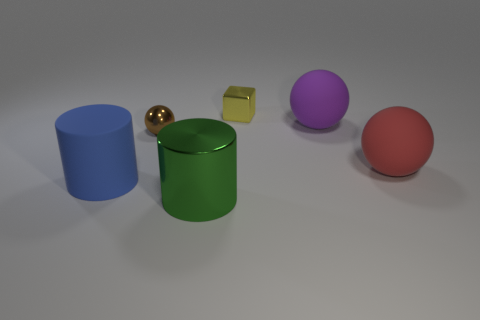There is a rubber ball behind the big matte ball that is in front of the large matte thing behind the tiny brown ball; how big is it?
Give a very brief answer. Large. What number of other things are the same color as the large rubber cylinder?
Provide a short and direct response. 0. There is a tiny object on the left side of the tiny yellow block; does it have the same color as the big shiny object?
Provide a short and direct response. No. How many objects are either blue rubber cylinders or metal objects?
Keep it short and to the point. 4. There is a thing that is in front of the blue thing; what is its color?
Offer a very short reply. Green. Are there fewer large blue things that are right of the green cylinder than cyan cylinders?
Give a very brief answer. No. Are there any other things that are the same size as the red rubber ball?
Your response must be concise. Yes. Is the material of the large blue cylinder the same as the large purple object?
Provide a succinct answer. Yes. What number of objects are either large green objects on the right side of the blue thing or cylinders that are in front of the large blue thing?
Offer a terse response. 1. Are there any green metal cylinders of the same size as the purple sphere?
Provide a succinct answer. Yes. 